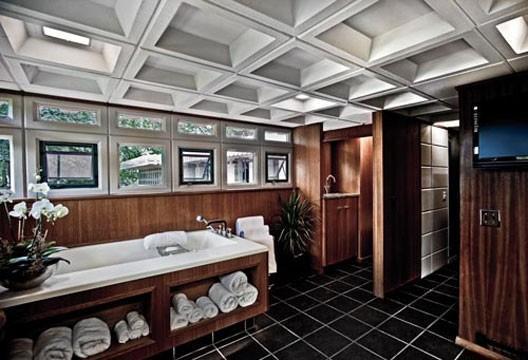How many tvs are in the photo?
Give a very brief answer. 2. How many potted plants are in the picture?
Give a very brief answer. 2. 